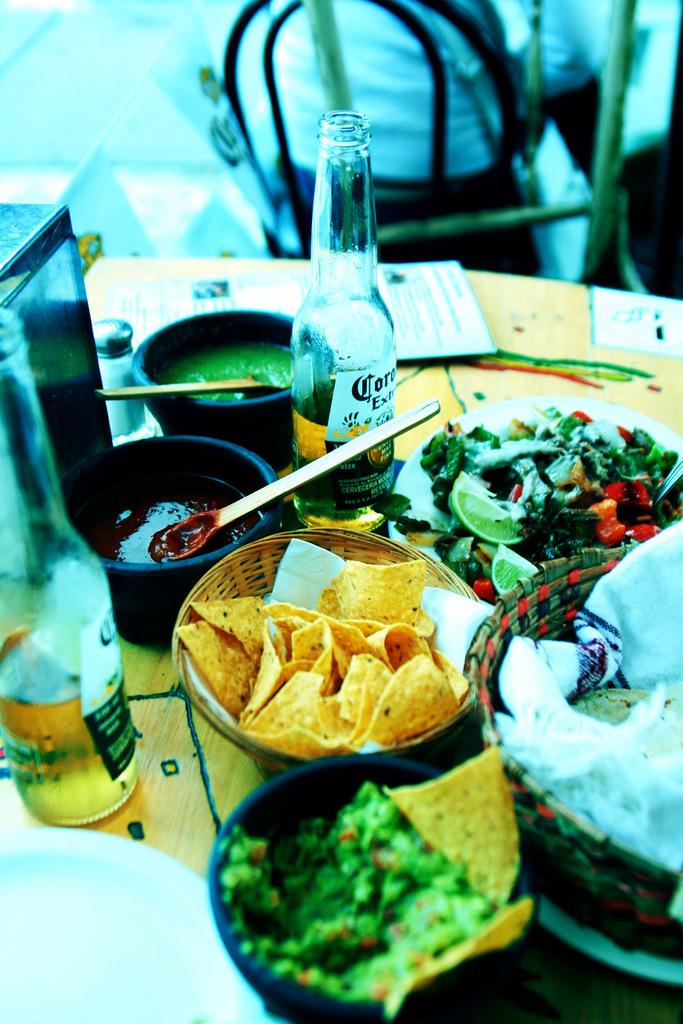What brand of beer is seen here?
Your response must be concise. Corona. Is that a corona extra?
Make the answer very short. Yes. 